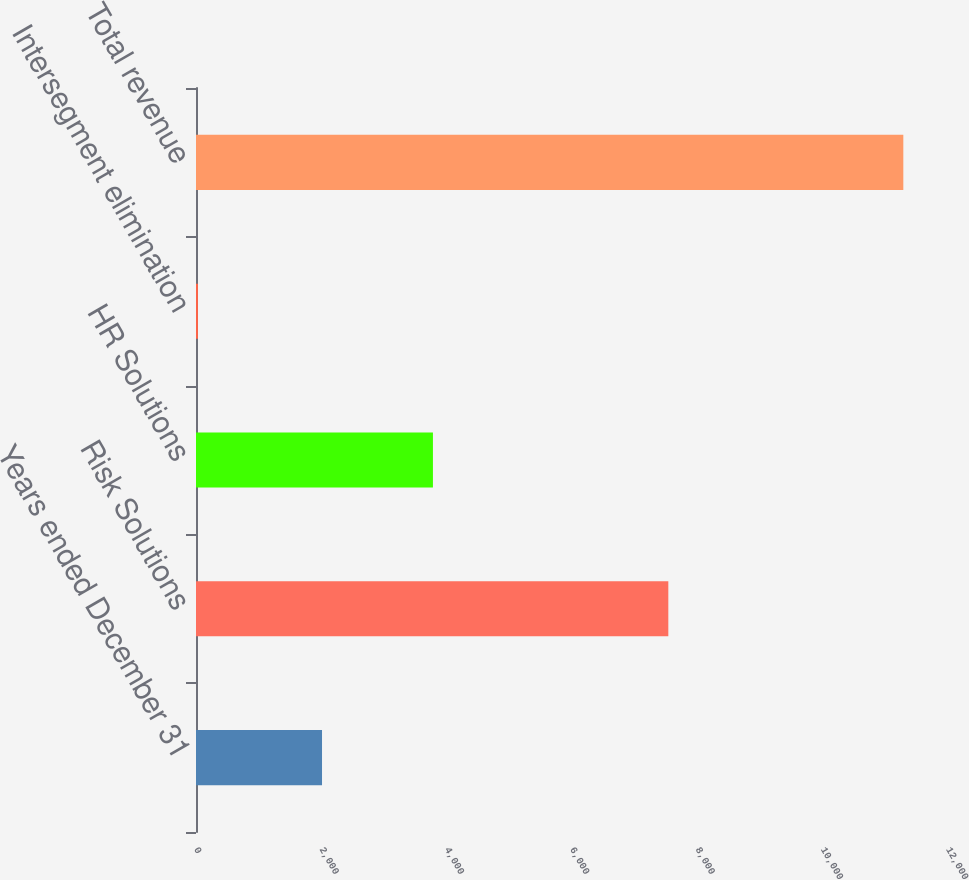Convert chart. <chart><loc_0><loc_0><loc_500><loc_500><bar_chart><fcel>Years ended December 31<fcel>Risk Solutions<fcel>HR Solutions<fcel>Intersegment elimination<fcel>Total revenue<nl><fcel>2011<fcel>7537<fcel>3781<fcel>31<fcel>11287<nl></chart> 